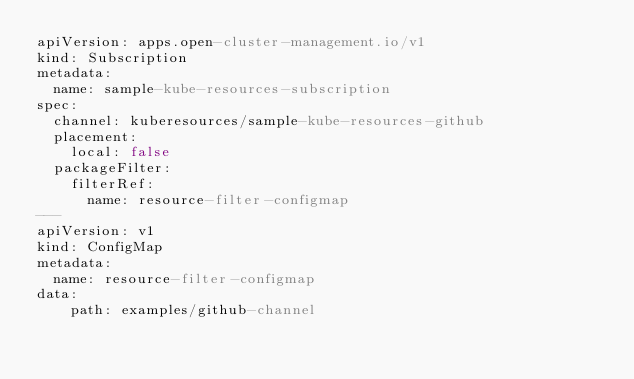Convert code to text. <code><loc_0><loc_0><loc_500><loc_500><_YAML_>apiVersion: apps.open-cluster-management.io/v1
kind: Subscription
metadata:
  name: sample-kube-resources-subscription
spec:
  channel: kuberesources/sample-kube-resources-github
  placement:
    local: false
  packageFilter:
    filterRef:
      name: resource-filter-configmap
---
apiVersion: v1
kind: ConfigMap
metadata:
  name: resource-filter-configmap
data:
    path: examples/github-channel</code> 